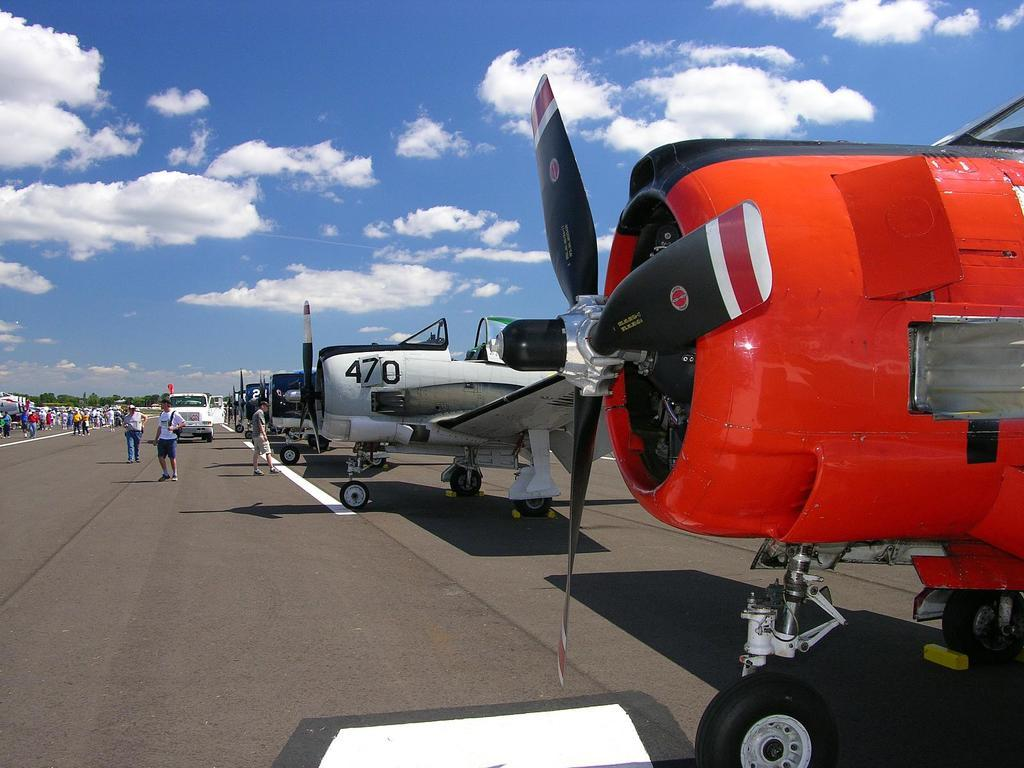What is the main subject of the image? The main subject of the image is airplanes. What else can be seen on the ground in the image? There is a vehicle on the ground in the image. What type of natural elements are present in the image? There are trees in the image. Who or what else is visible in the image? There are people in the image. What can be seen in the background of the image? The sky with clouds is visible in the background of the image. Can you see the sister of the person in the image playing in the ocean? There is no ocean or person's sister present in the image. 